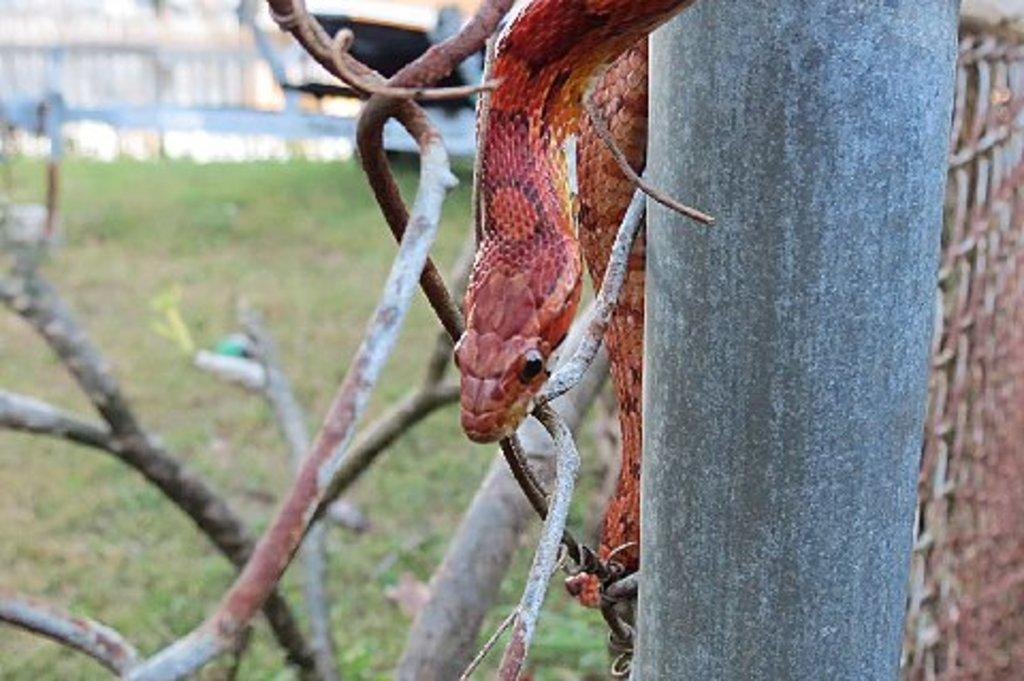What animal can be seen in the image? There is a snake in the image. Where is the snake located? The snake is on a tree. What type of vegetation is covering the ground in the image? The ground is covered with grass. What other object can be seen in the image? There is a pole present in the image. What shape is the cream in the image? There is no cream present in the image. 